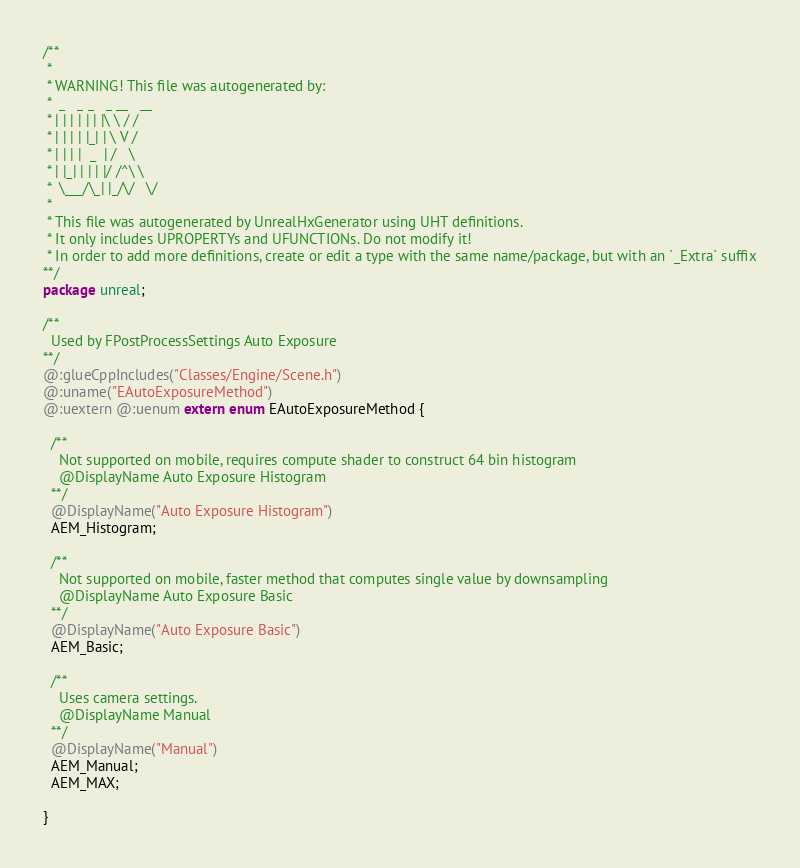Convert code to text. <code><loc_0><loc_0><loc_500><loc_500><_Haxe_>/**
 * 
 * WARNING! This file was autogenerated by: 
 *  _   _ _   _ __   __ 
 * | | | | | | |\ \ / / 
 * | | | | |_| | \ V /  
 * | | | |  _  | /   \  
 * | |_| | | | |/ /^\ \ 
 *  \___/\_| |_/\/   \/ 
 * 
 * This file was autogenerated by UnrealHxGenerator using UHT definitions.
 * It only includes UPROPERTYs and UFUNCTIONs. Do not modify it!
 * In order to add more definitions, create or edit a type with the same name/package, but with an `_Extra` suffix
**/
package unreal;

/**
  Used by FPostProcessSettings Auto Exposure
**/
@:glueCppIncludes("Classes/Engine/Scene.h")
@:uname("EAutoExposureMethod")
@:uextern @:uenum extern enum EAutoExposureMethod {
  
  /**
    Not supported on mobile, requires compute shader to construct 64 bin histogram
    @DisplayName Auto Exposure Histogram
  **/
  @DisplayName("Auto Exposure Histogram")
  AEM_Histogram;
  
  /**
    Not supported on mobile, faster method that computes single value by downsampling
    @DisplayName Auto Exposure Basic
  **/
  @DisplayName("Auto Exposure Basic")
  AEM_Basic;
  
  /**
    Uses camera settings.
    @DisplayName Manual
  **/
  @DisplayName("Manual")
  AEM_Manual;
  AEM_MAX;
  
}
</code> 